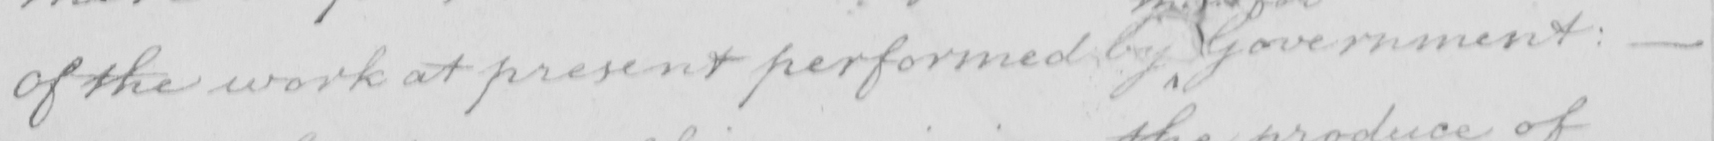Please transcribe the handwritten text in this image. of the work at present performed Government :   _  _  _ 